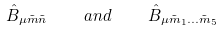Convert formula to latex. <formula><loc_0><loc_0><loc_500><loc_500>\hat { B } _ { \mu \tilde { m } \tilde { n } } \quad a n d \quad \hat { B } _ { \mu \tilde { m } _ { 1 } \dots \tilde { m } _ { 5 } }</formula> 